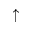Convert formula to latex. <formula><loc_0><loc_0><loc_500><loc_500>\uparrow</formula> 